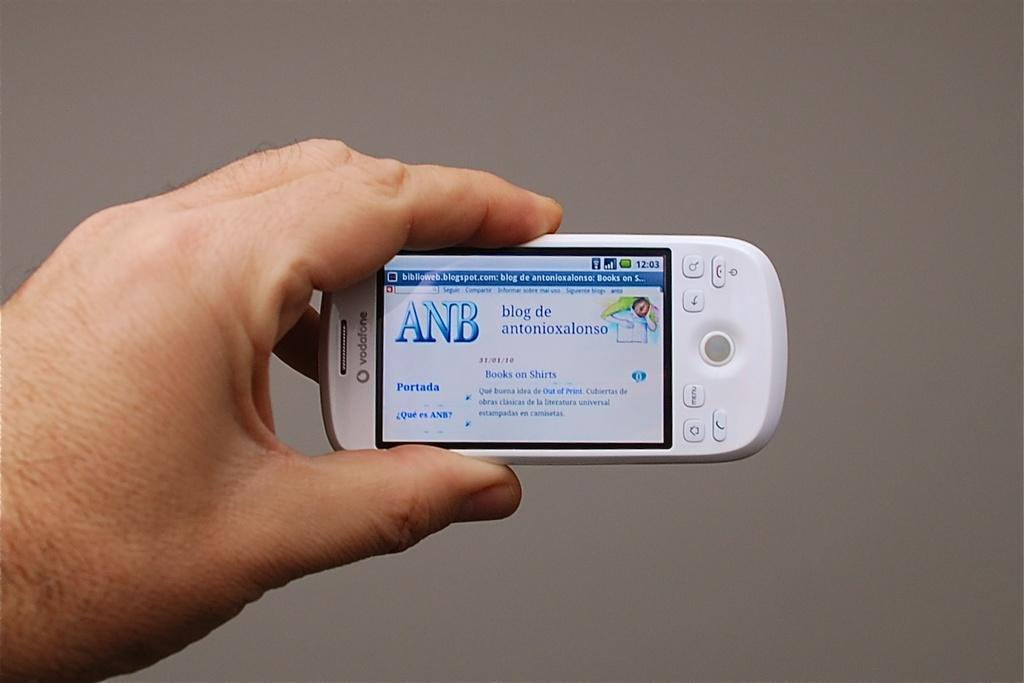<image>
Relay a brief, clear account of the picture shown. An electronic device with "ANB" on the screen held by a human hand. 